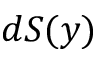Convert formula to latex. <formula><loc_0><loc_0><loc_500><loc_500>d S ( y )</formula> 